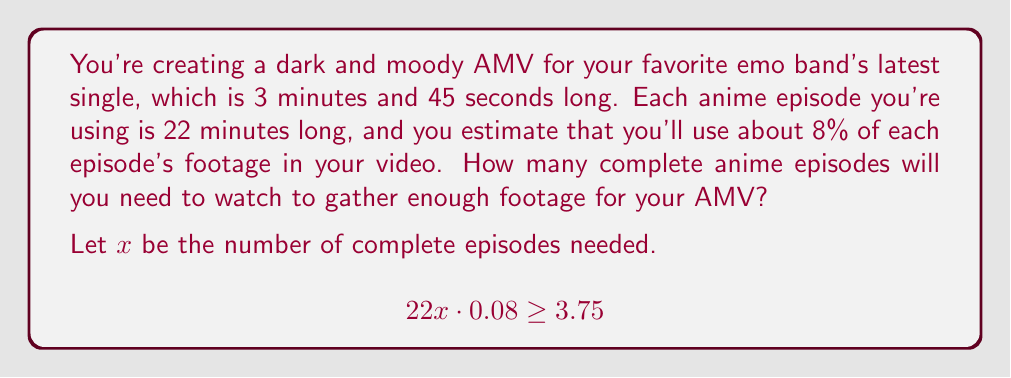Give your solution to this math problem. Let's break this down step-by-step:

1) First, we need to understand what the equation means:
   - $22x$ represents the total minutes of footage from $x$ episodes
   - $0.08$ is the fraction of each episode we'll use (8%)
   - $3.75$ is the length of the music video in minutes

2) Now, let's solve the inequality:

   $$22x \cdot 0.08 \geq 3.75$$

3) Simplify the left side:

   $$1.76x \geq 3.75$$

4) Divide both sides by 1.76:

   $$x \geq \frac{3.75}{1.76} \approx 2.13$$

5) Since we can only use whole episodes, we need to round up to the next integer.

6) Therefore, we need at least 3 complete episodes.

This solution ensures you have slightly more footage than needed, which is better for editing flexibility.
Answer: 3 episodes 